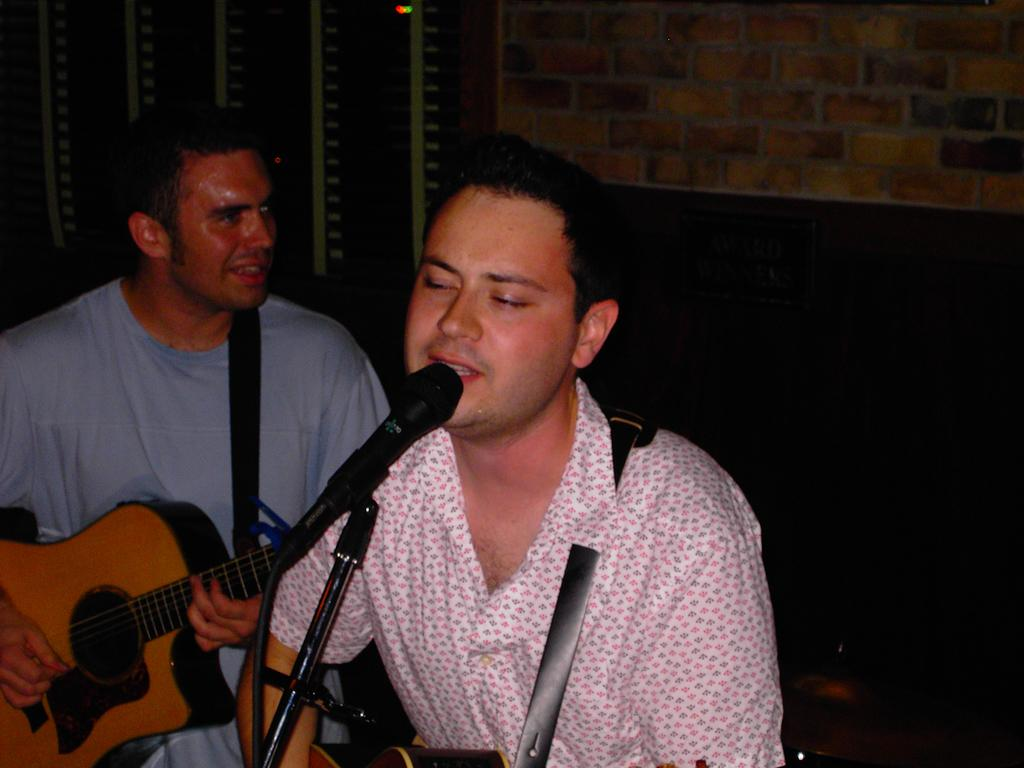What is the setting of the image? The image is inside a room. How many people are in the image? There are two persons in the image. What are the persons doing in the image? The persons are standing and playing guitar, and they are also singing. What object can be seen in the image that is related to singing? There is a microphone in the image. What type of pet can be seen wearing apparel in the image? There is no pet present in the image, and no one is wearing apparel. 